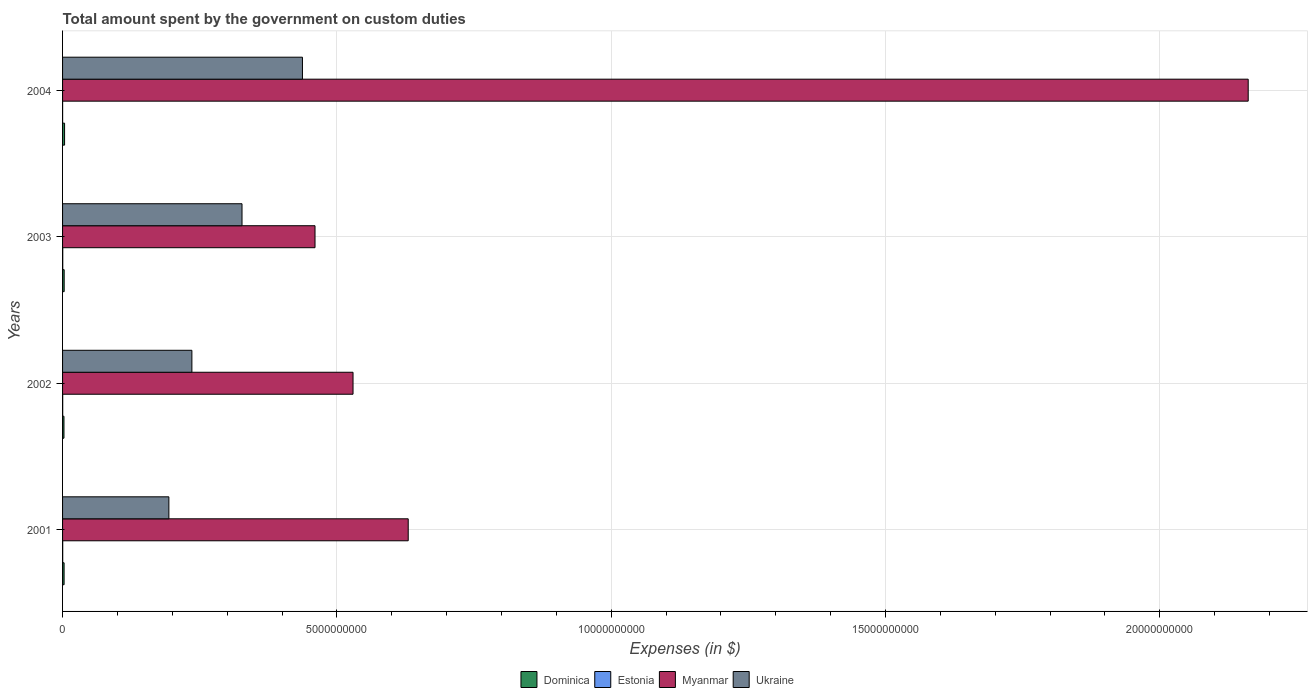Are the number of bars per tick equal to the number of legend labels?
Offer a very short reply. Yes. How many bars are there on the 1st tick from the top?
Your answer should be very brief. 4. What is the label of the 3rd group of bars from the top?
Offer a terse response. 2002. In how many cases, is the number of bars for a given year not equal to the number of legend labels?
Provide a short and direct response. 0. What is the amount spent on custom duties by the government in Estonia in 2002?
Give a very brief answer. 2.45e+06. Across all years, what is the maximum amount spent on custom duties by the government in Myanmar?
Provide a succinct answer. 2.16e+1. Across all years, what is the minimum amount spent on custom duties by the government in Dominica?
Provide a succinct answer. 2.56e+07. In which year was the amount spent on custom duties by the government in Estonia minimum?
Offer a terse response. 2004. What is the total amount spent on custom duties by the government in Dominica in the graph?
Offer a very short reply. 1.19e+08. What is the difference between the amount spent on custom duties by the government in Dominica in 2001 and that in 2004?
Make the answer very short. -8.90e+06. What is the difference between the amount spent on custom duties by the government in Myanmar in 2001 and the amount spent on custom duties by the government in Estonia in 2002?
Make the answer very short. 6.30e+09. What is the average amount spent on custom duties by the government in Estonia per year?
Give a very brief answer. 2.30e+06. In the year 2001, what is the difference between the amount spent on custom duties by the government in Ukraine and amount spent on custom duties by the government in Myanmar?
Make the answer very short. -4.36e+09. What is the ratio of the amount spent on custom duties by the government in Dominica in 2001 to that in 2002?
Keep it short and to the point. 1.09. What is the difference between the highest and the second highest amount spent on custom duties by the government in Ukraine?
Your answer should be compact. 1.10e+09. What is the difference between the highest and the lowest amount spent on custom duties by the government in Myanmar?
Provide a succinct answer. 1.70e+1. Is it the case that in every year, the sum of the amount spent on custom duties by the government in Ukraine and amount spent on custom duties by the government in Myanmar is greater than the sum of amount spent on custom duties by the government in Estonia and amount spent on custom duties by the government in Dominica?
Your answer should be compact. No. What does the 1st bar from the top in 2004 represents?
Your answer should be compact. Ukraine. What does the 3rd bar from the bottom in 2001 represents?
Your answer should be very brief. Myanmar. Is it the case that in every year, the sum of the amount spent on custom duties by the government in Myanmar and amount spent on custom duties by the government in Dominica is greater than the amount spent on custom duties by the government in Estonia?
Offer a very short reply. Yes. How many bars are there?
Offer a very short reply. 16. Are all the bars in the graph horizontal?
Provide a short and direct response. Yes. What is the difference between two consecutive major ticks on the X-axis?
Give a very brief answer. 5.00e+09. Does the graph contain grids?
Give a very brief answer. Yes. How are the legend labels stacked?
Your answer should be compact. Horizontal. What is the title of the graph?
Your answer should be very brief. Total amount spent by the government on custom duties. Does "Bolivia" appear as one of the legend labels in the graph?
Make the answer very short. No. What is the label or title of the X-axis?
Keep it short and to the point. Expenses (in $). What is the label or title of the Y-axis?
Ensure brevity in your answer.  Years. What is the Expenses (in $) of Dominica in 2001?
Keep it short and to the point. 2.78e+07. What is the Expenses (in $) in Estonia in 2001?
Provide a succinct answer. 2.56e+06. What is the Expenses (in $) in Myanmar in 2001?
Offer a very short reply. 6.30e+09. What is the Expenses (in $) in Ukraine in 2001?
Give a very brief answer. 1.94e+09. What is the Expenses (in $) in Dominica in 2002?
Provide a short and direct response. 2.56e+07. What is the Expenses (in $) of Estonia in 2002?
Give a very brief answer. 2.45e+06. What is the Expenses (in $) in Myanmar in 2002?
Make the answer very short. 5.30e+09. What is the Expenses (in $) of Ukraine in 2002?
Ensure brevity in your answer.  2.36e+09. What is the Expenses (in $) in Dominica in 2003?
Provide a succinct answer. 2.93e+07. What is the Expenses (in $) in Estonia in 2003?
Offer a very short reply. 3.41e+06. What is the Expenses (in $) of Myanmar in 2003?
Offer a terse response. 4.60e+09. What is the Expenses (in $) in Ukraine in 2003?
Make the answer very short. 3.27e+09. What is the Expenses (in $) of Dominica in 2004?
Your answer should be compact. 3.67e+07. What is the Expenses (in $) in Estonia in 2004?
Ensure brevity in your answer.  7.80e+05. What is the Expenses (in $) in Myanmar in 2004?
Provide a succinct answer. 2.16e+1. What is the Expenses (in $) of Ukraine in 2004?
Your response must be concise. 4.37e+09. Across all years, what is the maximum Expenses (in $) in Dominica?
Offer a terse response. 3.67e+07. Across all years, what is the maximum Expenses (in $) of Estonia?
Your answer should be very brief. 3.41e+06. Across all years, what is the maximum Expenses (in $) in Myanmar?
Your response must be concise. 2.16e+1. Across all years, what is the maximum Expenses (in $) in Ukraine?
Your answer should be compact. 4.37e+09. Across all years, what is the minimum Expenses (in $) of Dominica?
Offer a very short reply. 2.56e+07. Across all years, what is the minimum Expenses (in $) of Estonia?
Your answer should be compact. 7.80e+05. Across all years, what is the minimum Expenses (in $) in Myanmar?
Ensure brevity in your answer.  4.60e+09. Across all years, what is the minimum Expenses (in $) in Ukraine?
Make the answer very short. 1.94e+09. What is the total Expenses (in $) of Dominica in the graph?
Give a very brief answer. 1.19e+08. What is the total Expenses (in $) of Estonia in the graph?
Offer a terse response. 9.20e+06. What is the total Expenses (in $) of Myanmar in the graph?
Keep it short and to the point. 3.78e+1. What is the total Expenses (in $) of Ukraine in the graph?
Provide a short and direct response. 1.19e+1. What is the difference between the Expenses (in $) of Dominica in 2001 and that in 2002?
Offer a terse response. 2.20e+06. What is the difference between the Expenses (in $) in Myanmar in 2001 and that in 2002?
Offer a terse response. 1.01e+09. What is the difference between the Expenses (in $) in Ukraine in 2001 and that in 2002?
Ensure brevity in your answer.  -4.20e+08. What is the difference between the Expenses (in $) in Dominica in 2001 and that in 2003?
Offer a terse response. -1.50e+06. What is the difference between the Expenses (in $) of Estonia in 2001 and that in 2003?
Offer a very short reply. -8.50e+05. What is the difference between the Expenses (in $) of Myanmar in 2001 and that in 2003?
Your answer should be compact. 1.70e+09. What is the difference between the Expenses (in $) of Ukraine in 2001 and that in 2003?
Provide a succinct answer. -1.33e+09. What is the difference between the Expenses (in $) in Dominica in 2001 and that in 2004?
Ensure brevity in your answer.  -8.90e+06. What is the difference between the Expenses (in $) of Estonia in 2001 and that in 2004?
Ensure brevity in your answer.  1.78e+06. What is the difference between the Expenses (in $) in Myanmar in 2001 and that in 2004?
Ensure brevity in your answer.  -1.53e+1. What is the difference between the Expenses (in $) of Ukraine in 2001 and that in 2004?
Make the answer very short. -2.43e+09. What is the difference between the Expenses (in $) in Dominica in 2002 and that in 2003?
Give a very brief answer. -3.70e+06. What is the difference between the Expenses (in $) of Estonia in 2002 and that in 2003?
Give a very brief answer. -9.60e+05. What is the difference between the Expenses (in $) of Myanmar in 2002 and that in 2003?
Your answer should be very brief. 6.93e+08. What is the difference between the Expenses (in $) of Ukraine in 2002 and that in 2003?
Give a very brief answer. -9.14e+08. What is the difference between the Expenses (in $) in Dominica in 2002 and that in 2004?
Your response must be concise. -1.11e+07. What is the difference between the Expenses (in $) of Estonia in 2002 and that in 2004?
Provide a succinct answer. 1.67e+06. What is the difference between the Expenses (in $) in Myanmar in 2002 and that in 2004?
Your answer should be compact. -1.63e+1. What is the difference between the Expenses (in $) of Ukraine in 2002 and that in 2004?
Your response must be concise. -2.02e+09. What is the difference between the Expenses (in $) of Dominica in 2003 and that in 2004?
Your answer should be compact. -7.40e+06. What is the difference between the Expenses (in $) in Estonia in 2003 and that in 2004?
Give a very brief answer. 2.63e+06. What is the difference between the Expenses (in $) in Myanmar in 2003 and that in 2004?
Offer a terse response. -1.70e+1. What is the difference between the Expenses (in $) of Ukraine in 2003 and that in 2004?
Offer a terse response. -1.10e+09. What is the difference between the Expenses (in $) in Dominica in 2001 and the Expenses (in $) in Estonia in 2002?
Ensure brevity in your answer.  2.54e+07. What is the difference between the Expenses (in $) of Dominica in 2001 and the Expenses (in $) of Myanmar in 2002?
Your response must be concise. -5.27e+09. What is the difference between the Expenses (in $) in Dominica in 2001 and the Expenses (in $) in Ukraine in 2002?
Ensure brevity in your answer.  -2.33e+09. What is the difference between the Expenses (in $) in Estonia in 2001 and the Expenses (in $) in Myanmar in 2002?
Make the answer very short. -5.29e+09. What is the difference between the Expenses (in $) in Estonia in 2001 and the Expenses (in $) in Ukraine in 2002?
Provide a succinct answer. -2.36e+09. What is the difference between the Expenses (in $) in Myanmar in 2001 and the Expenses (in $) in Ukraine in 2002?
Provide a short and direct response. 3.94e+09. What is the difference between the Expenses (in $) of Dominica in 2001 and the Expenses (in $) of Estonia in 2003?
Offer a very short reply. 2.44e+07. What is the difference between the Expenses (in $) in Dominica in 2001 and the Expenses (in $) in Myanmar in 2003?
Keep it short and to the point. -4.57e+09. What is the difference between the Expenses (in $) of Dominica in 2001 and the Expenses (in $) of Ukraine in 2003?
Provide a short and direct response. -3.24e+09. What is the difference between the Expenses (in $) in Estonia in 2001 and the Expenses (in $) in Myanmar in 2003?
Provide a succinct answer. -4.60e+09. What is the difference between the Expenses (in $) of Estonia in 2001 and the Expenses (in $) of Ukraine in 2003?
Ensure brevity in your answer.  -3.27e+09. What is the difference between the Expenses (in $) of Myanmar in 2001 and the Expenses (in $) of Ukraine in 2003?
Make the answer very short. 3.03e+09. What is the difference between the Expenses (in $) in Dominica in 2001 and the Expenses (in $) in Estonia in 2004?
Ensure brevity in your answer.  2.70e+07. What is the difference between the Expenses (in $) of Dominica in 2001 and the Expenses (in $) of Myanmar in 2004?
Offer a very short reply. -2.16e+1. What is the difference between the Expenses (in $) in Dominica in 2001 and the Expenses (in $) in Ukraine in 2004?
Offer a terse response. -4.35e+09. What is the difference between the Expenses (in $) in Estonia in 2001 and the Expenses (in $) in Myanmar in 2004?
Keep it short and to the point. -2.16e+1. What is the difference between the Expenses (in $) in Estonia in 2001 and the Expenses (in $) in Ukraine in 2004?
Keep it short and to the point. -4.37e+09. What is the difference between the Expenses (in $) in Myanmar in 2001 and the Expenses (in $) in Ukraine in 2004?
Ensure brevity in your answer.  1.93e+09. What is the difference between the Expenses (in $) of Dominica in 2002 and the Expenses (in $) of Estonia in 2003?
Provide a short and direct response. 2.22e+07. What is the difference between the Expenses (in $) of Dominica in 2002 and the Expenses (in $) of Myanmar in 2003?
Provide a short and direct response. -4.58e+09. What is the difference between the Expenses (in $) of Dominica in 2002 and the Expenses (in $) of Ukraine in 2003?
Offer a terse response. -3.25e+09. What is the difference between the Expenses (in $) of Estonia in 2002 and the Expenses (in $) of Myanmar in 2003?
Your response must be concise. -4.60e+09. What is the difference between the Expenses (in $) of Estonia in 2002 and the Expenses (in $) of Ukraine in 2003?
Offer a very short reply. -3.27e+09. What is the difference between the Expenses (in $) of Myanmar in 2002 and the Expenses (in $) of Ukraine in 2003?
Offer a terse response. 2.02e+09. What is the difference between the Expenses (in $) in Dominica in 2002 and the Expenses (in $) in Estonia in 2004?
Your answer should be compact. 2.48e+07. What is the difference between the Expenses (in $) of Dominica in 2002 and the Expenses (in $) of Myanmar in 2004?
Your answer should be very brief. -2.16e+1. What is the difference between the Expenses (in $) of Dominica in 2002 and the Expenses (in $) of Ukraine in 2004?
Offer a terse response. -4.35e+09. What is the difference between the Expenses (in $) in Estonia in 2002 and the Expenses (in $) in Myanmar in 2004?
Provide a succinct answer. -2.16e+1. What is the difference between the Expenses (in $) in Estonia in 2002 and the Expenses (in $) in Ukraine in 2004?
Provide a succinct answer. -4.37e+09. What is the difference between the Expenses (in $) of Myanmar in 2002 and the Expenses (in $) of Ukraine in 2004?
Provide a succinct answer. 9.22e+08. What is the difference between the Expenses (in $) of Dominica in 2003 and the Expenses (in $) of Estonia in 2004?
Give a very brief answer. 2.85e+07. What is the difference between the Expenses (in $) in Dominica in 2003 and the Expenses (in $) in Myanmar in 2004?
Provide a succinct answer. -2.16e+1. What is the difference between the Expenses (in $) of Dominica in 2003 and the Expenses (in $) of Ukraine in 2004?
Your answer should be compact. -4.34e+09. What is the difference between the Expenses (in $) of Estonia in 2003 and the Expenses (in $) of Myanmar in 2004?
Offer a terse response. -2.16e+1. What is the difference between the Expenses (in $) in Estonia in 2003 and the Expenses (in $) in Ukraine in 2004?
Your answer should be very brief. -4.37e+09. What is the difference between the Expenses (in $) in Myanmar in 2003 and the Expenses (in $) in Ukraine in 2004?
Your answer should be very brief. 2.29e+08. What is the average Expenses (in $) of Dominica per year?
Offer a terse response. 2.98e+07. What is the average Expenses (in $) of Estonia per year?
Give a very brief answer. 2.30e+06. What is the average Expenses (in $) of Myanmar per year?
Ensure brevity in your answer.  9.45e+09. What is the average Expenses (in $) in Ukraine per year?
Your answer should be compact. 2.98e+09. In the year 2001, what is the difference between the Expenses (in $) in Dominica and Expenses (in $) in Estonia?
Your answer should be very brief. 2.52e+07. In the year 2001, what is the difference between the Expenses (in $) of Dominica and Expenses (in $) of Myanmar?
Provide a succinct answer. -6.27e+09. In the year 2001, what is the difference between the Expenses (in $) of Dominica and Expenses (in $) of Ukraine?
Provide a succinct answer. -1.91e+09. In the year 2001, what is the difference between the Expenses (in $) of Estonia and Expenses (in $) of Myanmar?
Offer a very short reply. -6.30e+09. In the year 2001, what is the difference between the Expenses (in $) in Estonia and Expenses (in $) in Ukraine?
Offer a very short reply. -1.94e+09. In the year 2001, what is the difference between the Expenses (in $) in Myanmar and Expenses (in $) in Ukraine?
Offer a terse response. 4.36e+09. In the year 2002, what is the difference between the Expenses (in $) of Dominica and Expenses (in $) of Estonia?
Offer a very short reply. 2.32e+07. In the year 2002, what is the difference between the Expenses (in $) of Dominica and Expenses (in $) of Myanmar?
Give a very brief answer. -5.27e+09. In the year 2002, what is the difference between the Expenses (in $) of Dominica and Expenses (in $) of Ukraine?
Your response must be concise. -2.33e+09. In the year 2002, what is the difference between the Expenses (in $) in Estonia and Expenses (in $) in Myanmar?
Provide a short and direct response. -5.29e+09. In the year 2002, what is the difference between the Expenses (in $) in Estonia and Expenses (in $) in Ukraine?
Ensure brevity in your answer.  -2.36e+09. In the year 2002, what is the difference between the Expenses (in $) of Myanmar and Expenses (in $) of Ukraine?
Your answer should be compact. 2.94e+09. In the year 2003, what is the difference between the Expenses (in $) in Dominica and Expenses (in $) in Estonia?
Your answer should be compact. 2.59e+07. In the year 2003, what is the difference between the Expenses (in $) of Dominica and Expenses (in $) of Myanmar?
Keep it short and to the point. -4.57e+09. In the year 2003, what is the difference between the Expenses (in $) of Dominica and Expenses (in $) of Ukraine?
Ensure brevity in your answer.  -3.24e+09. In the year 2003, what is the difference between the Expenses (in $) in Estonia and Expenses (in $) in Myanmar?
Offer a very short reply. -4.60e+09. In the year 2003, what is the difference between the Expenses (in $) of Estonia and Expenses (in $) of Ukraine?
Your answer should be compact. -3.27e+09. In the year 2003, what is the difference between the Expenses (in $) of Myanmar and Expenses (in $) of Ukraine?
Your response must be concise. 1.33e+09. In the year 2004, what is the difference between the Expenses (in $) in Dominica and Expenses (in $) in Estonia?
Give a very brief answer. 3.59e+07. In the year 2004, what is the difference between the Expenses (in $) in Dominica and Expenses (in $) in Myanmar?
Provide a short and direct response. -2.16e+1. In the year 2004, what is the difference between the Expenses (in $) of Dominica and Expenses (in $) of Ukraine?
Your answer should be compact. -4.34e+09. In the year 2004, what is the difference between the Expenses (in $) of Estonia and Expenses (in $) of Myanmar?
Make the answer very short. -2.16e+1. In the year 2004, what is the difference between the Expenses (in $) of Estonia and Expenses (in $) of Ukraine?
Offer a very short reply. -4.37e+09. In the year 2004, what is the difference between the Expenses (in $) of Myanmar and Expenses (in $) of Ukraine?
Offer a terse response. 1.72e+1. What is the ratio of the Expenses (in $) in Dominica in 2001 to that in 2002?
Your response must be concise. 1.09. What is the ratio of the Expenses (in $) in Estonia in 2001 to that in 2002?
Your response must be concise. 1.04. What is the ratio of the Expenses (in $) of Myanmar in 2001 to that in 2002?
Make the answer very short. 1.19. What is the ratio of the Expenses (in $) of Ukraine in 2001 to that in 2002?
Make the answer very short. 0.82. What is the ratio of the Expenses (in $) of Dominica in 2001 to that in 2003?
Make the answer very short. 0.95. What is the ratio of the Expenses (in $) of Estonia in 2001 to that in 2003?
Offer a very short reply. 0.75. What is the ratio of the Expenses (in $) in Myanmar in 2001 to that in 2003?
Provide a short and direct response. 1.37. What is the ratio of the Expenses (in $) in Ukraine in 2001 to that in 2003?
Provide a succinct answer. 0.59. What is the ratio of the Expenses (in $) in Dominica in 2001 to that in 2004?
Your answer should be very brief. 0.76. What is the ratio of the Expenses (in $) of Estonia in 2001 to that in 2004?
Your response must be concise. 3.28. What is the ratio of the Expenses (in $) of Myanmar in 2001 to that in 2004?
Offer a terse response. 0.29. What is the ratio of the Expenses (in $) of Ukraine in 2001 to that in 2004?
Provide a short and direct response. 0.44. What is the ratio of the Expenses (in $) of Dominica in 2002 to that in 2003?
Offer a terse response. 0.87. What is the ratio of the Expenses (in $) in Estonia in 2002 to that in 2003?
Provide a short and direct response. 0.72. What is the ratio of the Expenses (in $) of Myanmar in 2002 to that in 2003?
Provide a succinct answer. 1.15. What is the ratio of the Expenses (in $) in Ukraine in 2002 to that in 2003?
Your answer should be compact. 0.72. What is the ratio of the Expenses (in $) of Dominica in 2002 to that in 2004?
Your response must be concise. 0.7. What is the ratio of the Expenses (in $) in Estonia in 2002 to that in 2004?
Keep it short and to the point. 3.14. What is the ratio of the Expenses (in $) in Myanmar in 2002 to that in 2004?
Ensure brevity in your answer.  0.24. What is the ratio of the Expenses (in $) of Ukraine in 2002 to that in 2004?
Your response must be concise. 0.54. What is the ratio of the Expenses (in $) in Dominica in 2003 to that in 2004?
Keep it short and to the point. 0.8. What is the ratio of the Expenses (in $) in Estonia in 2003 to that in 2004?
Your answer should be compact. 4.37. What is the ratio of the Expenses (in $) in Myanmar in 2003 to that in 2004?
Offer a very short reply. 0.21. What is the ratio of the Expenses (in $) of Ukraine in 2003 to that in 2004?
Your answer should be compact. 0.75. What is the difference between the highest and the second highest Expenses (in $) in Dominica?
Your answer should be compact. 7.40e+06. What is the difference between the highest and the second highest Expenses (in $) of Estonia?
Offer a very short reply. 8.50e+05. What is the difference between the highest and the second highest Expenses (in $) in Myanmar?
Provide a short and direct response. 1.53e+1. What is the difference between the highest and the second highest Expenses (in $) of Ukraine?
Your answer should be very brief. 1.10e+09. What is the difference between the highest and the lowest Expenses (in $) in Dominica?
Keep it short and to the point. 1.11e+07. What is the difference between the highest and the lowest Expenses (in $) in Estonia?
Provide a succinct answer. 2.63e+06. What is the difference between the highest and the lowest Expenses (in $) in Myanmar?
Provide a short and direct response. 1.70e+1. What is the difference between the highest and the lowest Expenses (in $) in Ukraine?
Make the answer very short. 2.43e+09. 